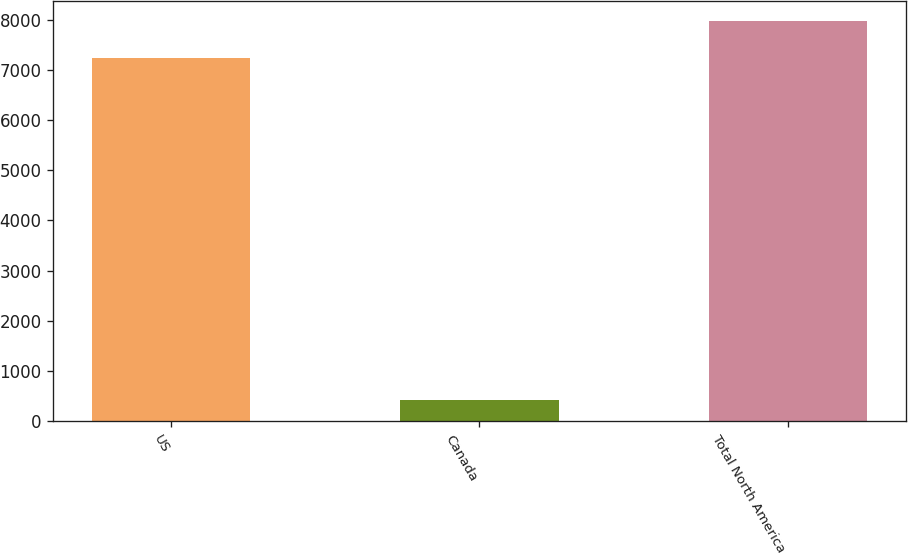<chart> <loc_0><loc_0><loc_500><loc_500><bar_chart><fcel>US<fcel>Canada<fcel>Total North America<nl><fcel>7245<fcel>413<fcel>7969.5<nl></chart> 